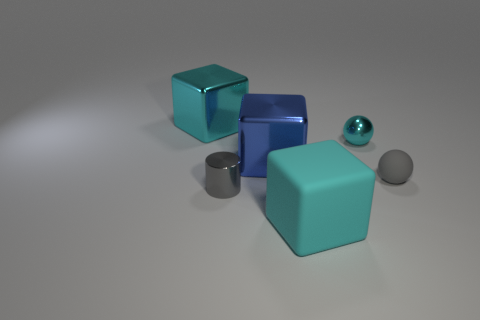Can you describe the lighting in the scene? The lighting in the image appears to be soft and diffused, with a single light source coming from above. This creates subtle shadows below each object, giving the scene a calm and even look. The reflections on the objects' surfaces also indicate the angle and relative strength of the light source. 